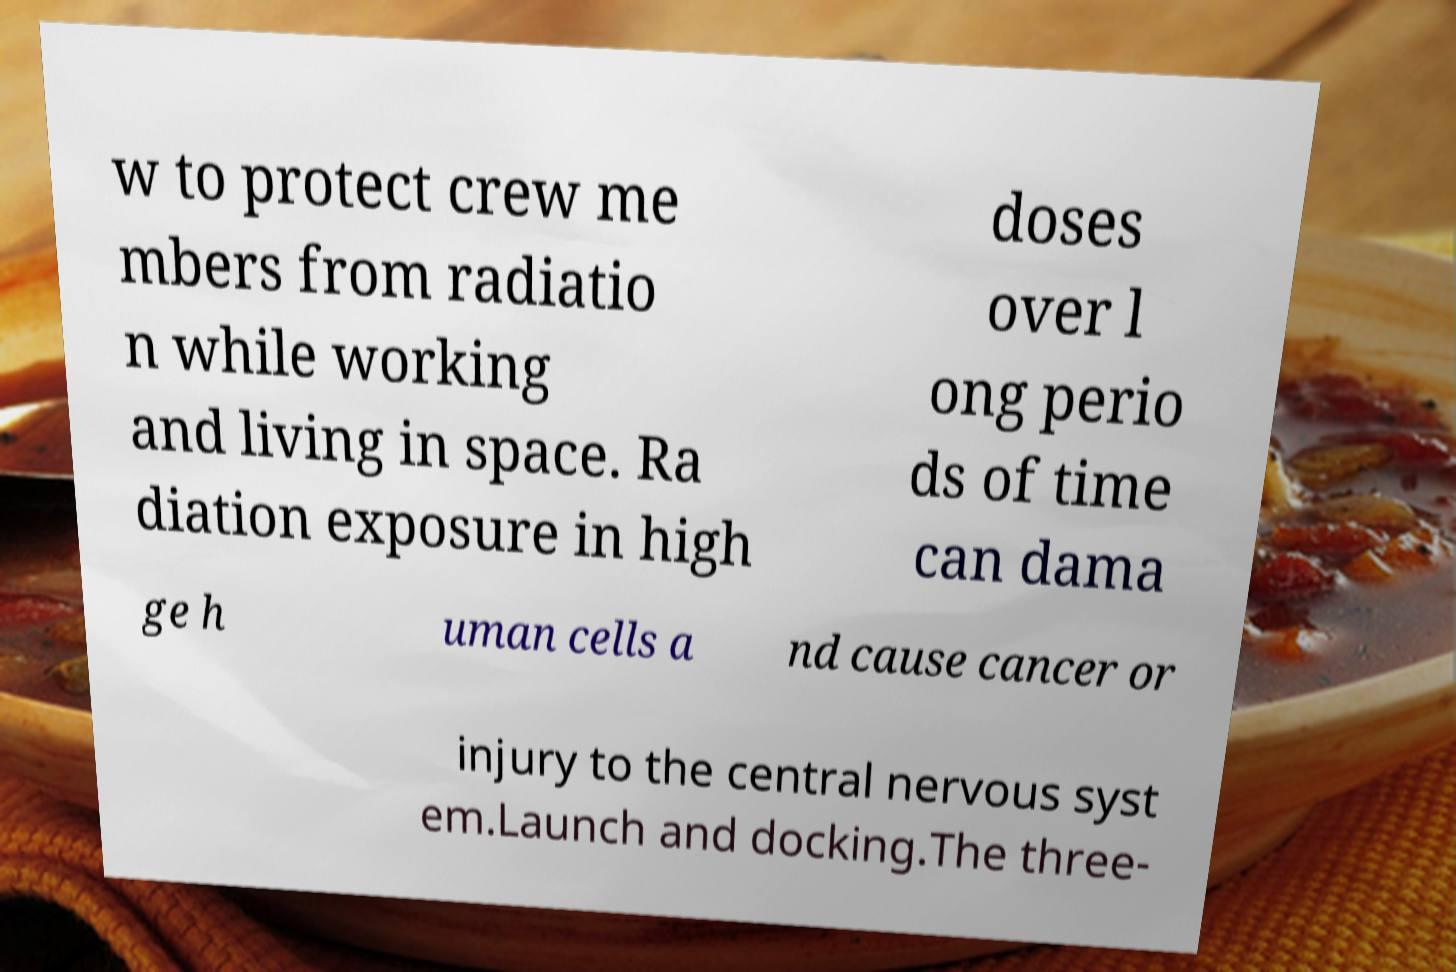There's text embedded in this image that I need extracted. Can you transcribe it verbatim? w to protect crew me mbers from radiatio n while working and living in space. Ra diation exposure in high doses over l ong perio ds of time can dama ge h uman cells a nd cause cancer or injury to the central nervous syst em.Launch and docking.The three- 